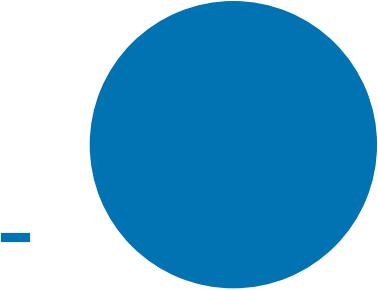Convert chart to OTSL. <chart><loc_0><loc_0><loc_500><loc_500><pie_chart><ecel><nl><fcel>100.0%<nl></chart> 